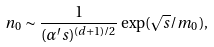<formula> <loc_0><loc_0><loc_500><loc_500>n _ { 0 } \sim \frac { 1 } { ( \alpha ^ { \prime } s ) ^ { ( d + 1 ) / 2 } } \exp ( \sqrt { s } / m _ { 0 } ) ,</formula> 